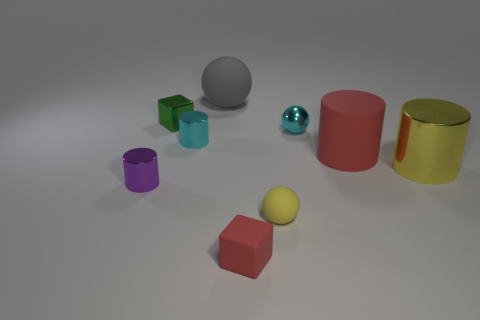Subtract all small spheres. How many spheres are left? 1 Subtract 1 cylinders. How many cylinders are left? 3 Add 1 big cylinders. How many objects exist? 10 Subtract all brown cylinders. Subtract all cyan balls. How many cylinders are left? 4 Subtract all cylinders. How many objects are left? 5 Add 2 small cyan spheres. How many small cyan spheres exist? 3 Subtract 0 blue cylinders. How many objects are left? 9 Subtract all tiny brown blocks. Subtract all tiny shiny cylinders. How many objects are left? 7 Add 4 cylinders. How many cylinders are left? 8 